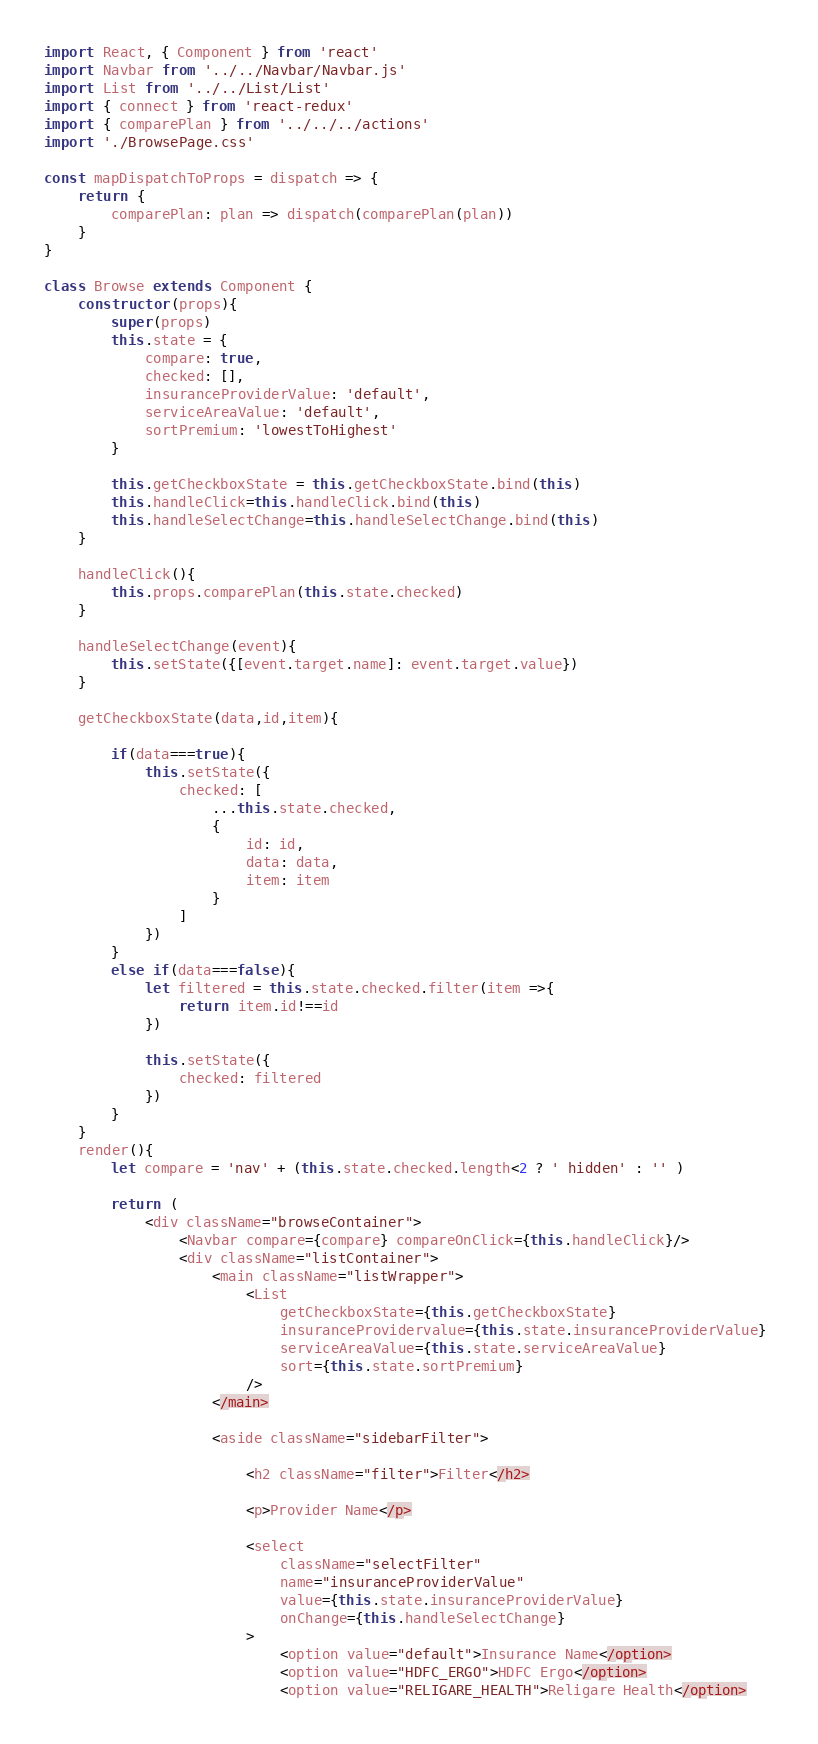Convert code to text. <code><loc_0><loc_0><loc_500><loc_500><_JavaScript_>import React, { Component } from 'react'
import Navbar from '../../Navbar/Navbar.js'
import List from '../../List/List'
import { connect } from 'react-redux'
import { comparePlan } from '../../../actions'
import './BrowsePage.css'

const mapDispatchToProps = dispatch => {
	return {
		comparePlan: plan => dispatch(comparePlan(plan))
	}
}

class Browse extends Component {
	constructor(props){
		super(props)
		this.state = {
			compare: true,
			checked: [],
			insuranceProviderValue: 'default',
			serviceAreaValue: 'default',
			sortPremium: 'lowestToHighest'
		}

		this.getCheckboxState = this.getCheckboxState.bind(this)
		this.handleClick=this.handleClick.bind(this)
		this.handleSelectChange=this.handleSelectChange.bind(this)
	}

	handleClick(){
		this.props.comparePlan(this.state.checked)
	}

	handleSelectChange(event){
		this.setState({[event.target.name]: event.target.value})
	}

	getCheckboxState(data,id,item){

		if(data===true){
			this.setState({
				checked: [
					...this.state.checked, 
					{
						id: id,
						data: data,
						item: item
					}
				]
			})
		}
		else if(data===false){
			let filtered = this.state.checked.filter(item =>{
				return item.id!==id
			})
			
			this.setState({
				checked: filtered
			})
		}
	}
	render(){
		let compare = 'nav' + (this.state.checked.length<2 ? ' hidden' : '' )
		
		return (
			<div className="browseContainer">
				<Navbar compare={compare} compareOnClick={this.handleClick}/>
				<div className="listContainer">
					<main className="listWrapper">
						<List 
							getCheckboxState={this.getCheckboxState} 
							insuranceProvidervalue={this.state.insuranceProviderValue} 
							serviceAreaValue={this.state.serviceAreaValue}
							sort={this.state.sortPremium}
						/>
					</main>

					<aside className="sidebarFilter">

						<h2 className="filter">Filter</h2>

						<p>Provider Name</p>

						<select 
							className="selectFilter"
							name="insuranceProviderValue" 
							value={this.state.insuranceProviderValue} 
							onChange={this.handleSelectChange}
						>
							<option value="default">Insurance Name</option>
							<option value="HDFC_ERGO">HDFC Ergo</option>
							<option value="RELIGARE_HEALTH">Religare Health</option></code> 